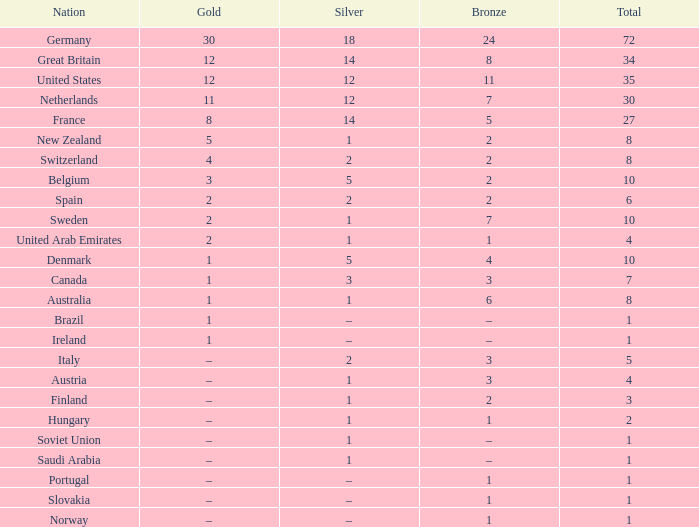What is Gold, when Total is 6? 2.0. 